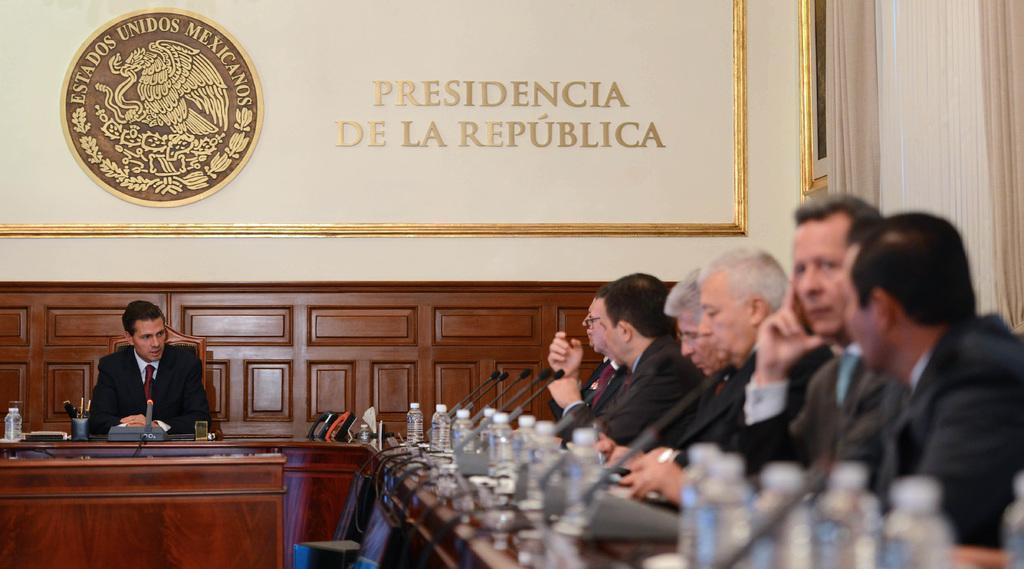Please provide a concise description of this image. In the image we can see there are people who are sitting on chair and in front of them there is a table on which water bottles and mike kept 